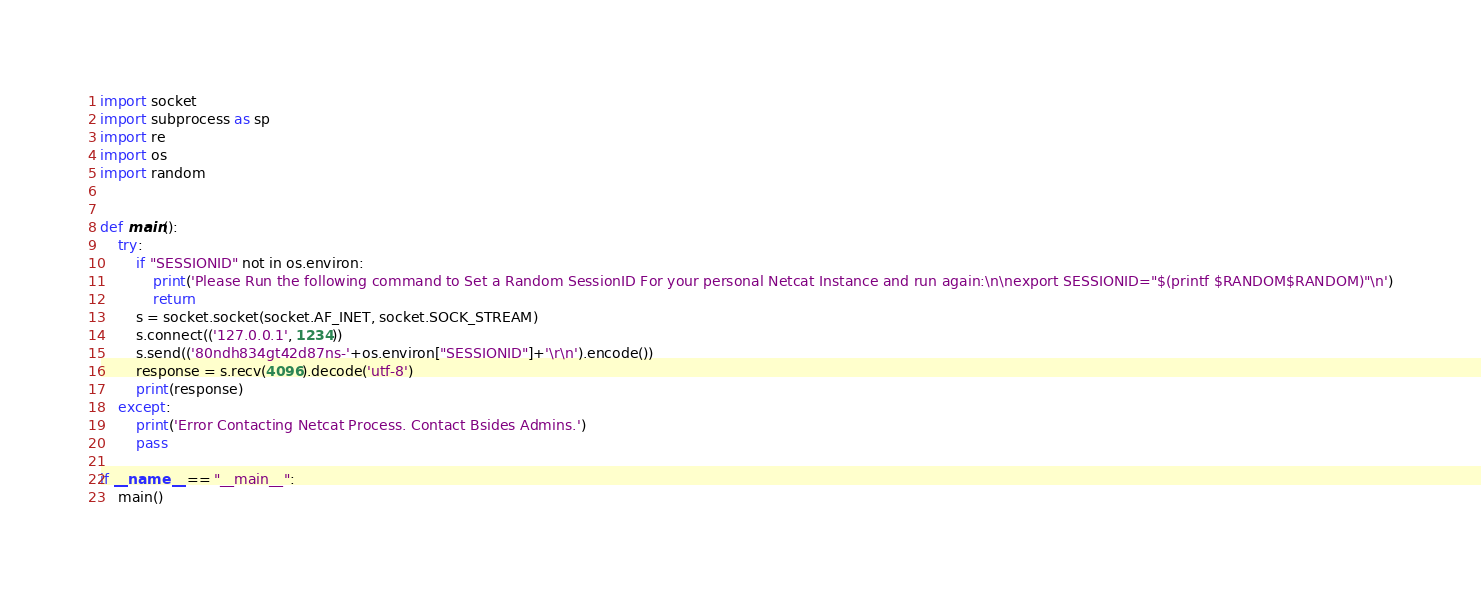Convert code to text. <code><loc_0><loc_0><loc_500><loc_500><_Python_>import socket
import subprocess as sp
import re
import os
import random


def main():
    try:
        if "SESSIONID" not in os.environ:
            print('Please Run the following command to Set a Random SessionID For your personal Netcat Instance and run again:\n\nexport SESSIONID="$(printf $RANDOM$RANDOM)"\n')
            return
        s = socket.socket(socket.AF_INET, socket.SOCK_STREAM)
        s.connect(('127.0.0.1', 1234))
        s.send(('80ndh834gt42d87ns-'+os.environ["SESSIONID"]+'\r\n').encode())
        response = s.recv(4096).decode('utf-8')
        print(response)
    except:
        print('Error Contacting Netcat Process. Contact Bsides Admins.')
        pass

if __name__ == "__main__":
    main()</code> 